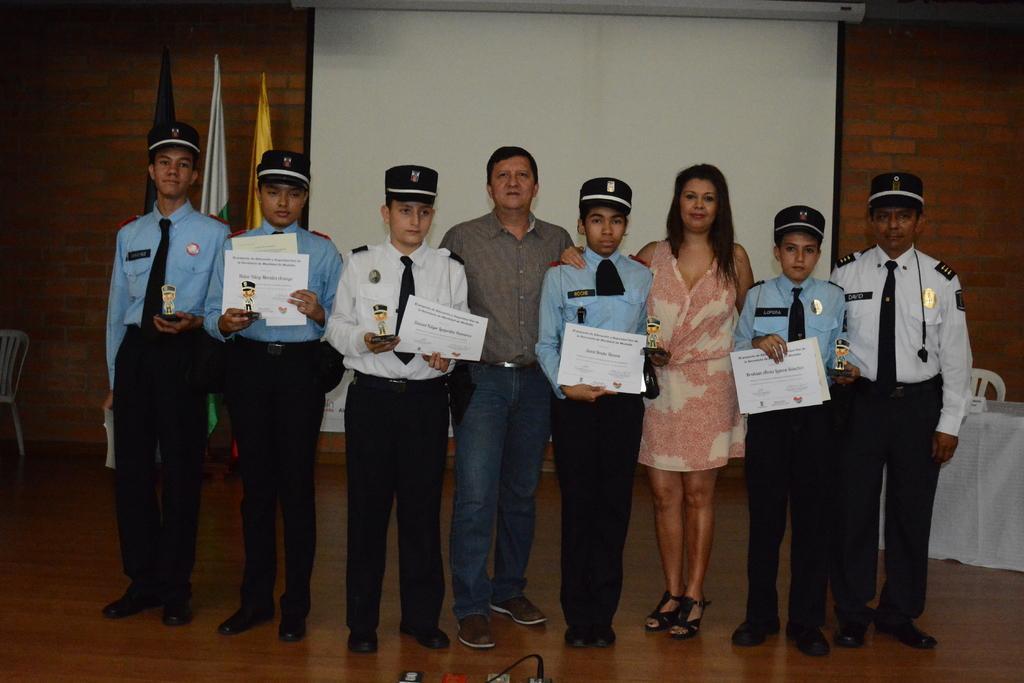Could you give a brief overview of what you see in this image? In this image in the center there are persons standing and holding papers in their hands. In the background there are flags, there is a white screen and on the right side there is a table which is covered with a white colour cloth and there is a chair. On the left side there is an empty chair which is white in colour and there is a wall which is red in colour. 